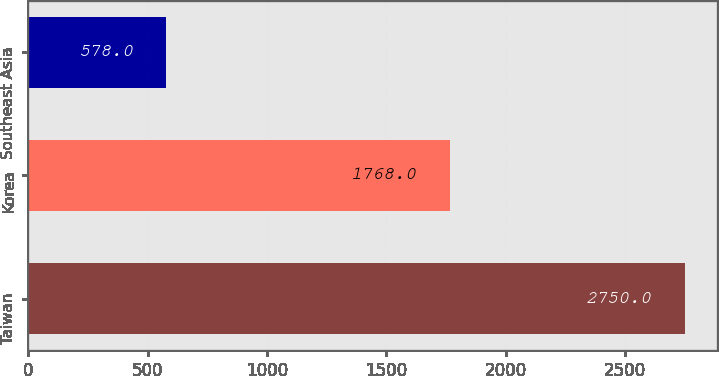Convert chart. <chart><loc_0><loc_0><loc_500><loc_500><bar_chart><fcel>Taiwan<fcel>Korea<fcel>Southeast Asia<nl><fcel>2750<fcel>1768<fcel>578<nl></chart> 